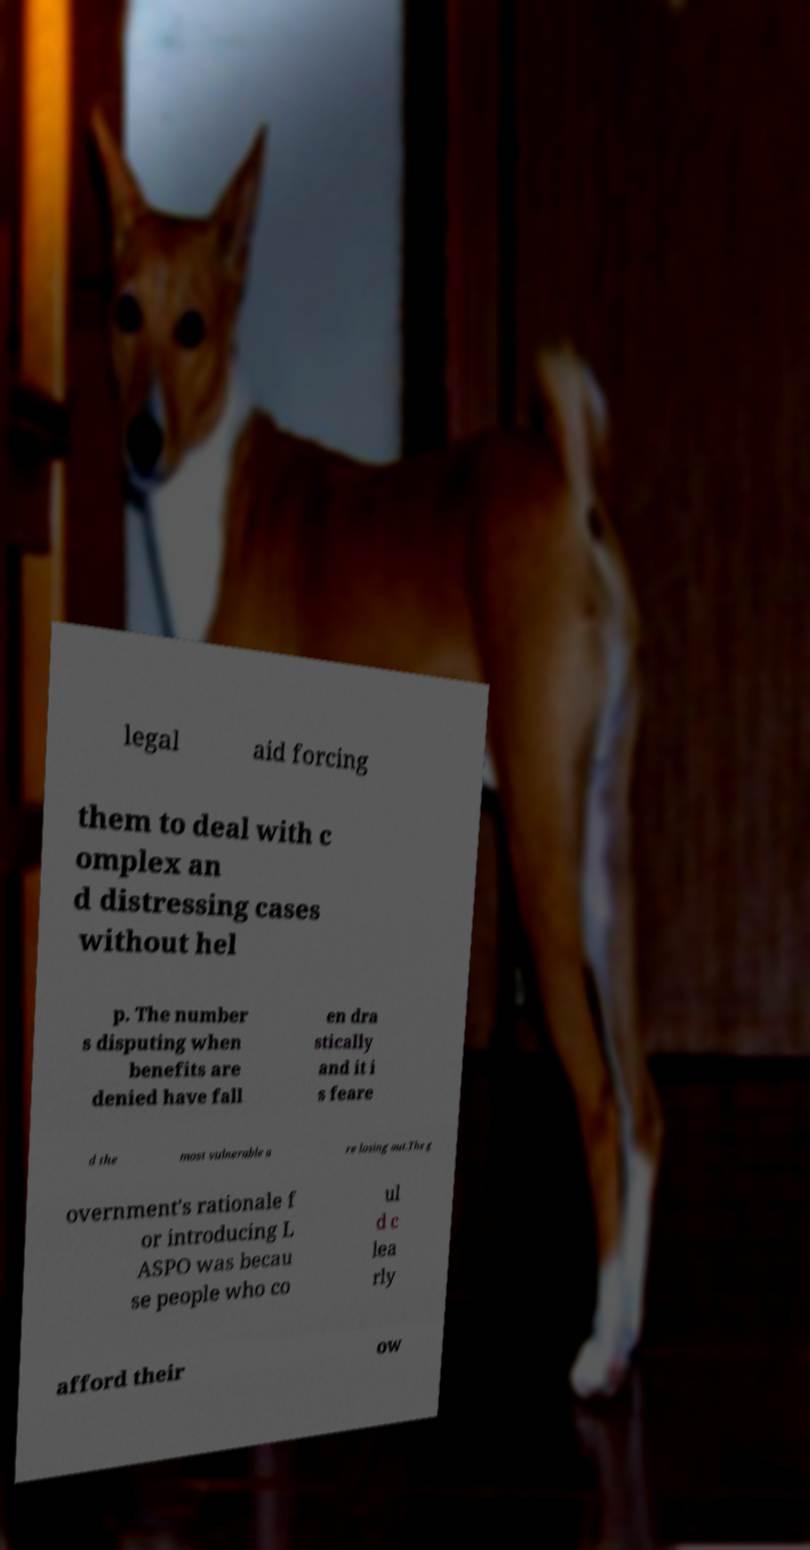Please read and relay the text visible in this image. What does it say? legal aid forcing them to deal with c omplex an d distressing cases without hel p. The number s disputing when benefits are denied have fall en dra stically and it i s feare d the most vulnerable a re losing out.The g overnment's rationale f or introducing L ASPO was becau se people who co ul d c lea rly afford their ow 